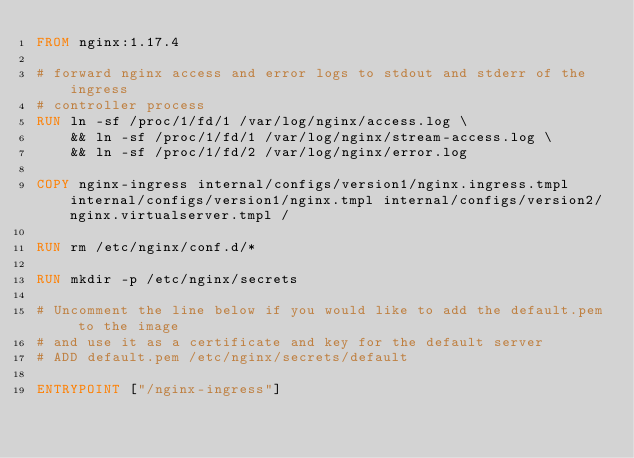Convert code to text. <code><loc_0><loc_0><loc_500><loc_500><_Dockerfile_>FROM nginx:1.17.4

# forward nginx access and error logs to stdout and stderr of the ingress
# controller process
RUN ln -sf /proc/1/fd/1 /var/log/nginx/access.log \
	&& ln -sf /proc/1/fd/1 /var/log/nginx/stream-access.log \
	&& ln -sf /proc/1/fd/2 /var/log/nginx/error.log

COPY nginx-ingress internal/configs/version1/nginx.ingress.tmpl internal/configs/version1/nginx.tmpl internal/configs/version2/nginx.virtualserver.tmpl /

RUN rm /etc/nginx/conf.d/*

RUN mkdir -p /etc/nginx/secrets

# Uncomment the line below if you would like to add the default.pem to the image
# and use it as a certificate and key for the default server
# ADD default.pem /etc/nginx/secrets/default

ENTRYPOINT ["/nginx-ingress"]
</code> 